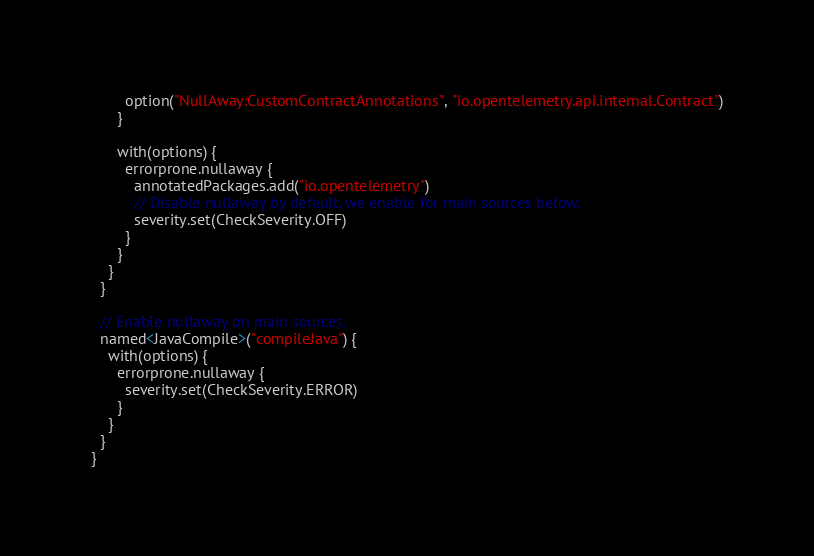<code> <loc_0><loc_0><loc_500><loc_500><_Kotlin_>        option("NullAway:CustomContractAnnotations", "io.opentelemetry.api.internal.Contract")
      }

      with(options) {
        errorprone.nullaway {
          annotatedPackages.add("io.opentelemetry")
          // Disable nullaway by default, we enable for main sources below.
          severity.set(CheckSeverity.OFF)
        }
      }
    }
  }

  // Enable nullaway on main sources.
  named<JavaCompile>("compileJava") {
    with(options) {
      errorprone.nullaway {
        severity.set(CheckSeverity.ERROR)
      }
    }
  }
}
</code> 